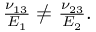Convert formula to latex. <formula><loc_0><loc_0><loc_500><loc_500>\begin{array} { r } { \frac { \nu _ { 1 3 } } { E _ { 1 } } \neq \frac { \nu _ { 2 3 } } { E _ { 2 } } . } \end{array}</formula> 